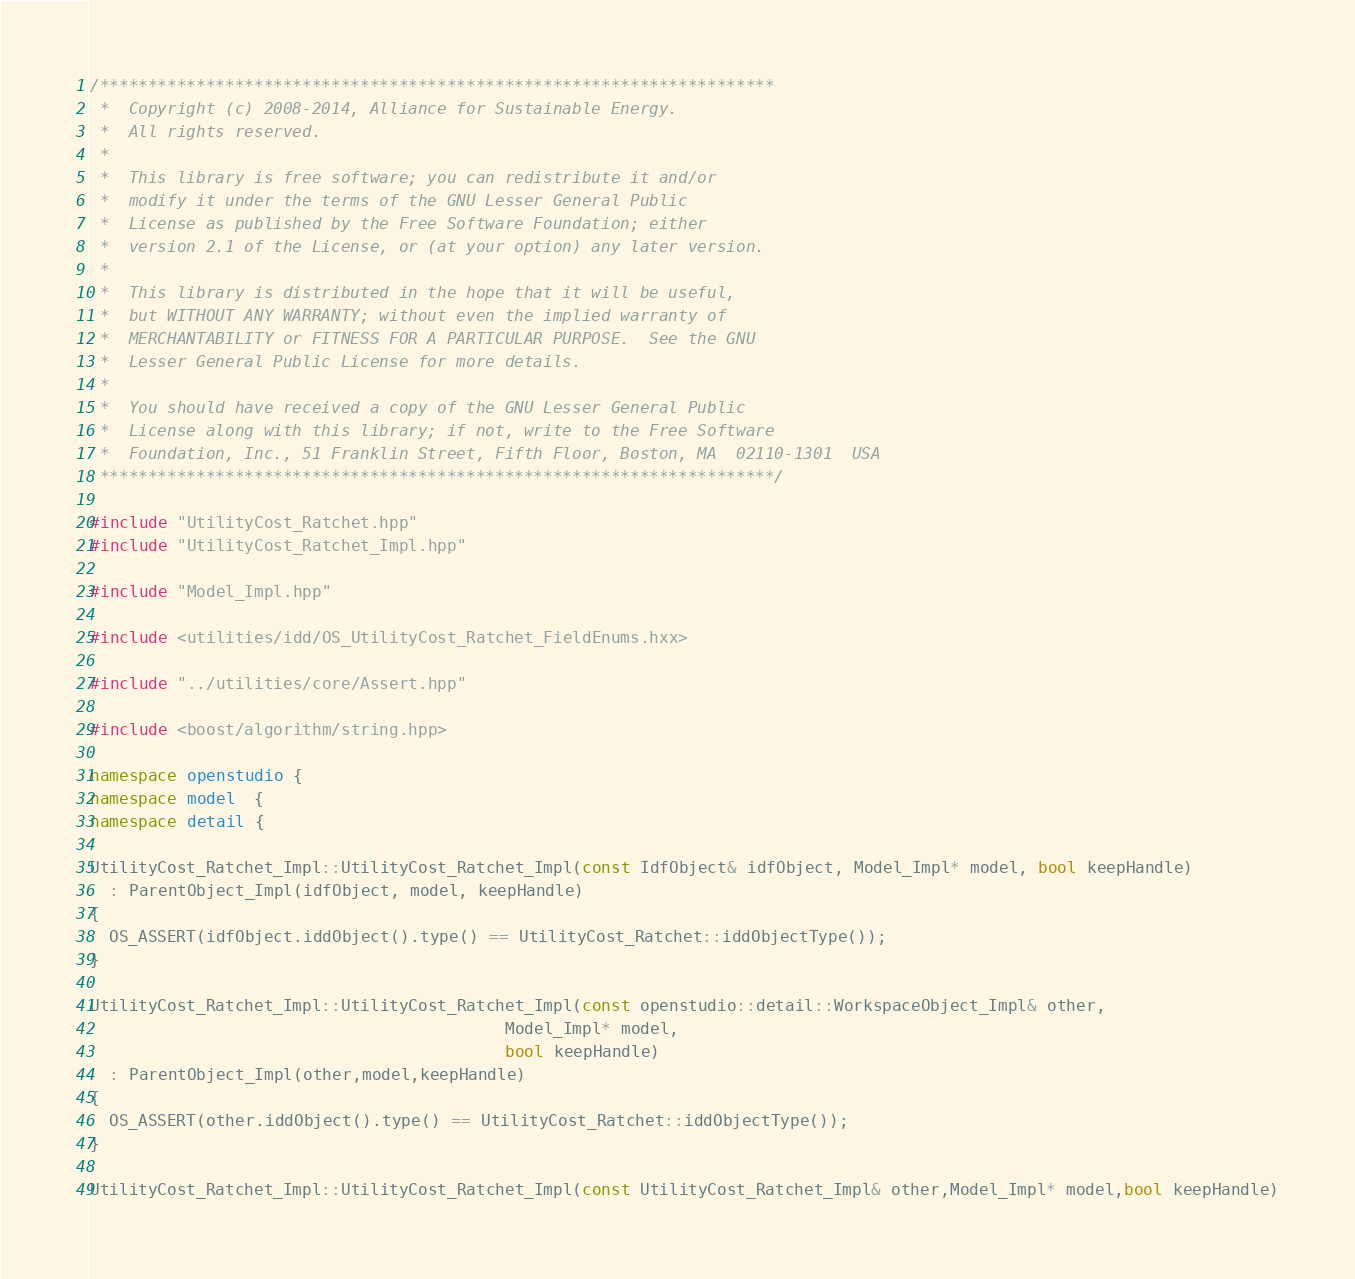<code> <loc_0><loc_0><loc_500><loc_500><_C++_>/**********************************************************************
 *  Copyright (c) 2008-2014, Alliance for Sustainable Energy.
 *  All rights reserved.
 *
 *  This library is free software; you can redistribute it and/or
 *  modify it under the terms of the GNU Lesser General Public
 *  License as published by the Free Software Foundation; either
 *  version 2.1 of the License, or (at your option) any later version.
 *
 *  This library is distributed in the hope that it will be useful,
 *  but WITHOUT ANY WARRANTY; without even the implied warranty of
 *  MERCHANTABILITY or FITNESS FOR A PARTICULAR PURPOSE.  See the GNU
 *  Lesser General Public License for more details.
 *
 *  You should have received a copy of the GNU Lesser General Public
 *  License along with this library; if not, write to the Free Software
 *  Foundation, Inc., 51 Franklin Street, Fifth Floor, Boston, MA  02110-1301  USA
 **********************************************************************/

#include "UtilityCost_Ratchet.hpp"
#include "UtilityCost_Ratchet_Impl.hpp"

#include "Model_Impl.hpp"

#include <utilities/idd/OS_UtilityCost_Ratchet_FieldEnums.hxx>

#include "../utilities/core/Assert.hpp"

#include <boost/algorithm/string.hpp>

namespace openstudio {
namespace model  {
namespace detail {

UtilityCost_Ratchet_Impl::UtilityCost_Ratchet_Impl(const IdfObject& idfObject, Model_Impl* model, bool keepHandle)
  : ParentObject_Impl(idfObject, model, keepHandle)
{
  OS_ASSERT(idfObject.iddObject().type() == UtilityCost_Ratchet::iddObjectType());
}

UtilityCost_Ratchet_Impl::UtilityCost_Ratchet_Impl(const openstudio::detail::WorkspaceObject_Impl& other,
                                           Model_Impl* model,
                                           bool keepHandle)
  : ParentObject_Impl(other,model,keepHandle)
{
  OS_ASSERT(other.iddObject().type() == UtilityCost_Ratchet::iddObjectType());
}

UtilityCost_Ratchet_Impl::UtilityCost_Ratchet_Impl(const UtilityCost_Ratchet_Impl& other,Model_Impl* model,bool keepHandle)</code> 